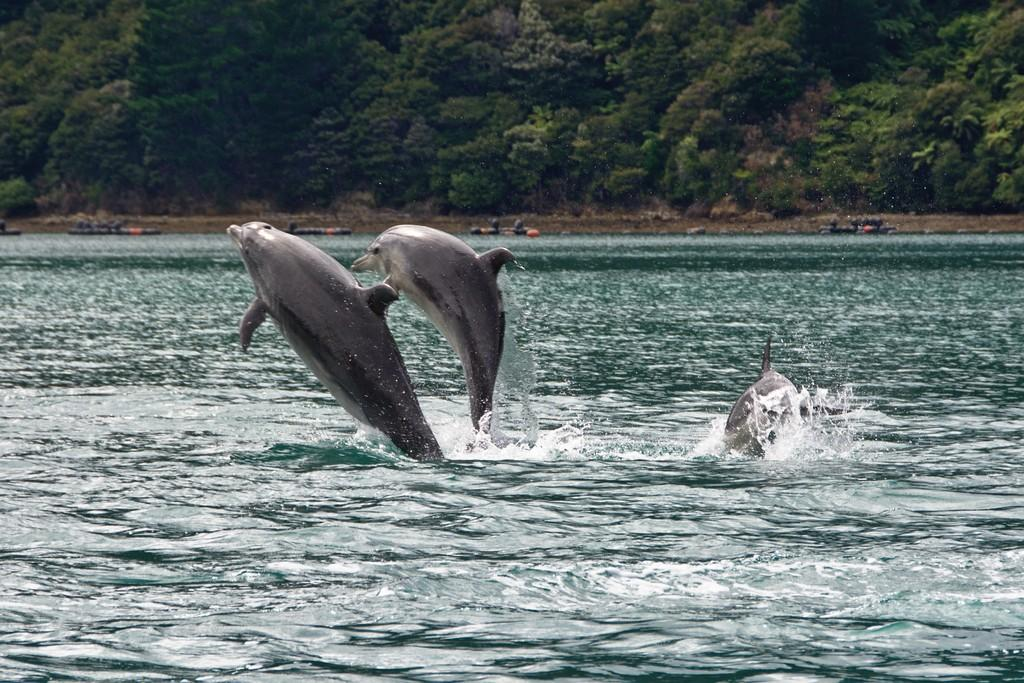What animals are present in the image? There are dolphins in the image. What are the dolphins doing in the image? The dolphins are swimming in the water. What type of water can be seen in the image? There is an ocean visible in the image. What can be seen in the background of the image? There are trees in the background of the image. What color is the stocking worn by the dolphin in the image? There are no dolphins wearing stockings in the image; dolphins do not wear clothing. 